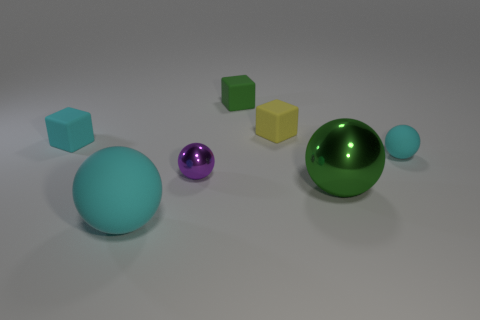What is the color of the tiny thing that is both to the left of the tiny cyan ball and in front of the cyan block?
Offer a terse response. Purple. How many tiny cyan cylinders are there?
Keep it short and to the point. 0. Are there any other things that are the same size as the yellow thing?
Your response must be concise. Yes. Do the large cyan object and the small yellow object have the same material?
Offer a very short reply. Yes. Do the rubber ball behind the tiny metal object and the block right of the small green object have the same size?
Provide a succinct answer. Yes. Are there fewer tiny rubber spheres than big red matte cubes?
Provide a short and direct response. No. What number of matte things are either tiny purple balls or big green cubes?
Your response must be concise. 0. Is there a small purple sphere behind the tiny cyan matte object on the right side of the big cyan thing?
Keep it short and to the point. No. Does the cyan thing that is to the right of the small purple metallic object have the same material as the small yellow cube?
Your answer should be very brief. Yes. What number of other things are there of the same color as the big metallic object?
Your answer should be very brief. 1. 